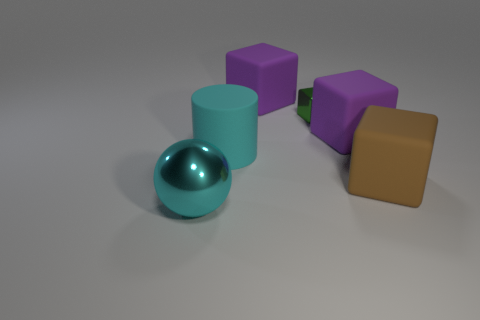Subtract all large matte cubes. How many cubes are left? 1 Subtract all purple cubes. How many cubes are left? 2 Subtract all spheres. How many objects are left? 5 Add 5 big cyan objects. How many big cyan objects exist? 7 Add 3 blocks. How many objects exist? 9 Subtract 0 purple balls. How many objects are left? 6 Subtract 1 blocks. How many blocks are left? 3 Subtract all gray spheres. Subtract all brown cylinders. How many spheres are left? 1 Subtract all brown cubes. How many blue balls are left? 0 Subtract all small purple cylinders. Subtract all small things. How many objects are left? 5 